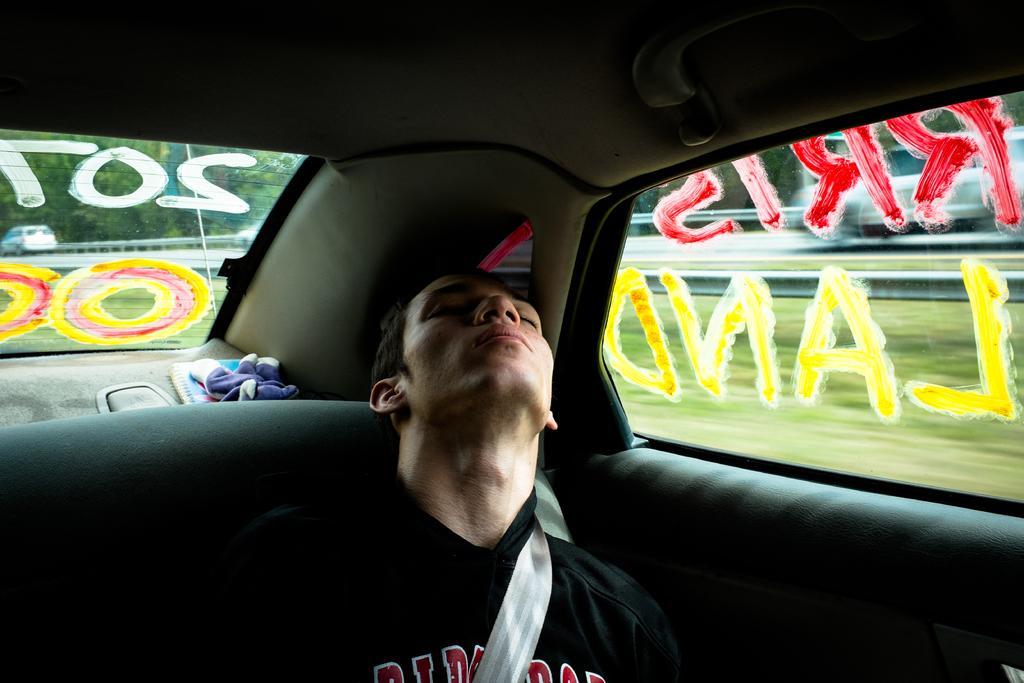Could you give a brief overview of what you see in this image? This is the picture of a man sleeping inside the car. 